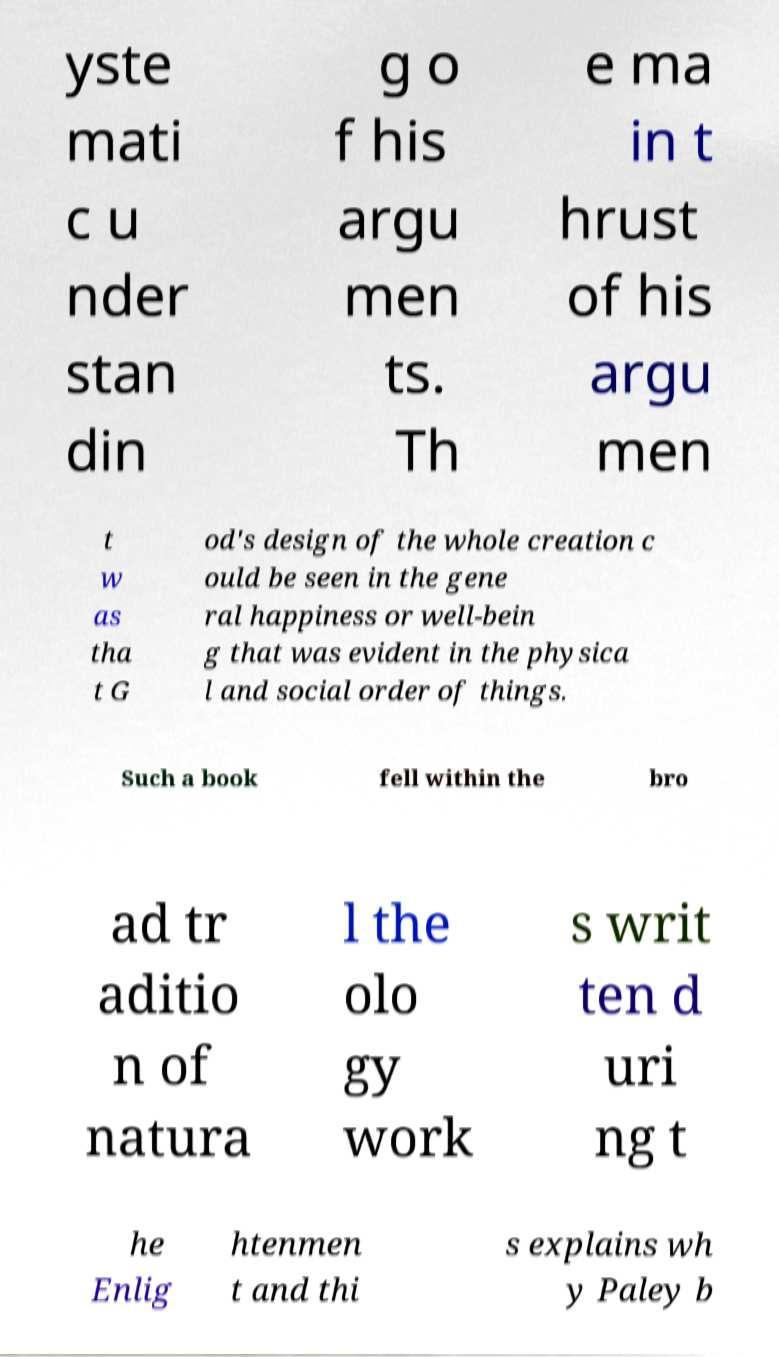There's text embedded in this image that I need extracted. Can you transcribe it verbatim? yste mati c u nder stan din g o f his argu men ts. Th e ma in t hrust of his argu men t w as tha t G od's design of the whole creation c ould be seen in the gene ral happiness or well-bein g that was evident in the physica l and social order of things. Such a book fell within the bro ad tr aditio n of natura l the olo gy work s writ ten d uri ng t he Enlig htenmen t and thi s explains wh y Paley b 